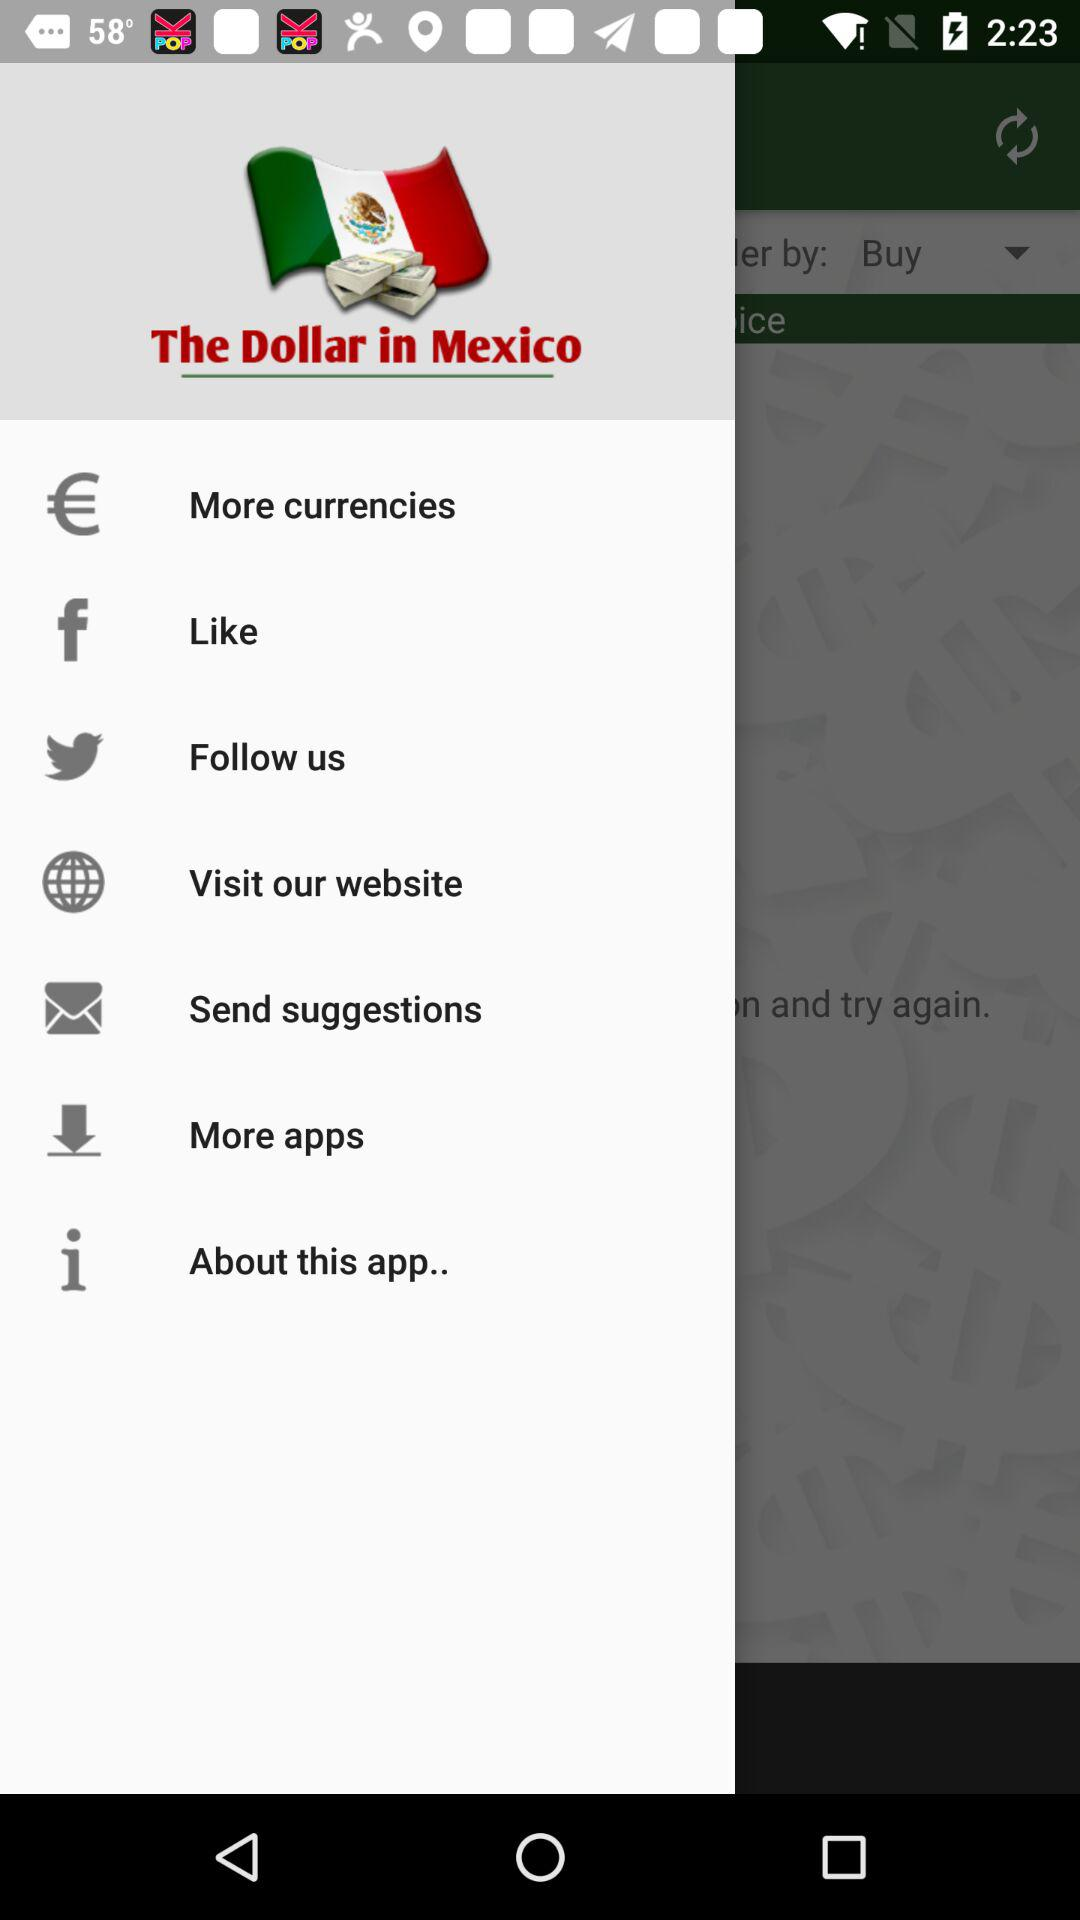What is the name of the application? The name of the application is "The Dollar in Mexico". 